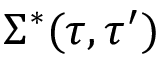Convert formula to latex. <formula><loc_0><loc_0><loc_500><loc_500>\Sigma ^ { * } ( \tau , \tau ^ { \prime } )</formula> 